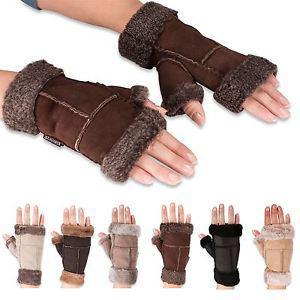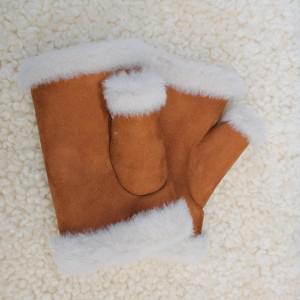The first image is the image on the left, the second image is the image on the right. Evaluate the accuracy of this statement regarding the images: "One image shows human hands wearing gloves, and one shows a pair of unworn gloves.". Is it true? Answer yes or no. Yes. The first image is the image on the left, the second image is the image on the right. For the images displayed, is the sentence "A dark brown pair of gloves are worn by a human hand." factually correct? Answer yes or no. Yes. 